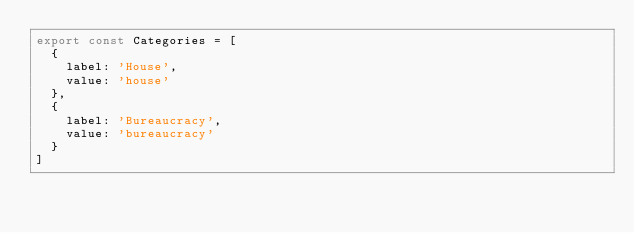<code> <loc_0><loc_0><loc_500><loc_500><_TypeScript_>export const Categories = [
  {
    label: 'House',
    value: 'house'
  },
  {
    label: 'Bureaucracy',
    value: 'bureaucracy'
  }
]
</code> 